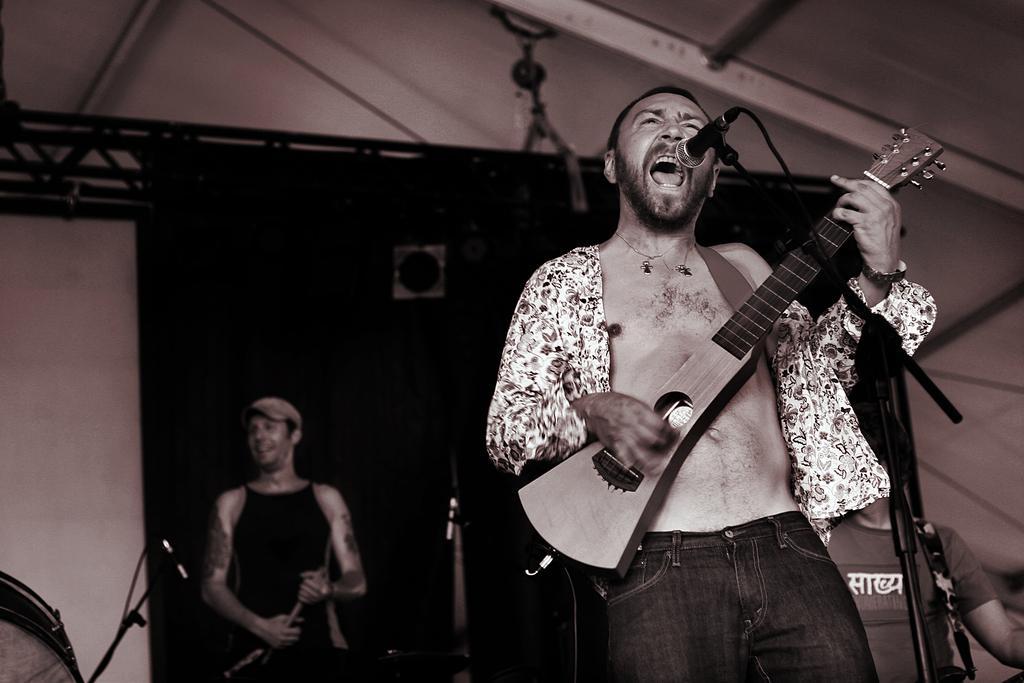How would you summarize this image in a sentence or two? A person is singing on mic and playing guitar. Behind him there are few people playing musical instruments and a banner. 